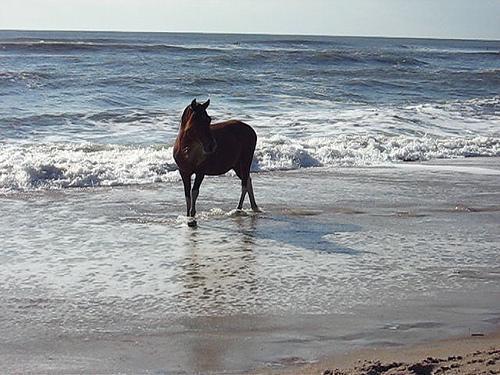How many horses are on the water?
Give a very brief answer. 1. 